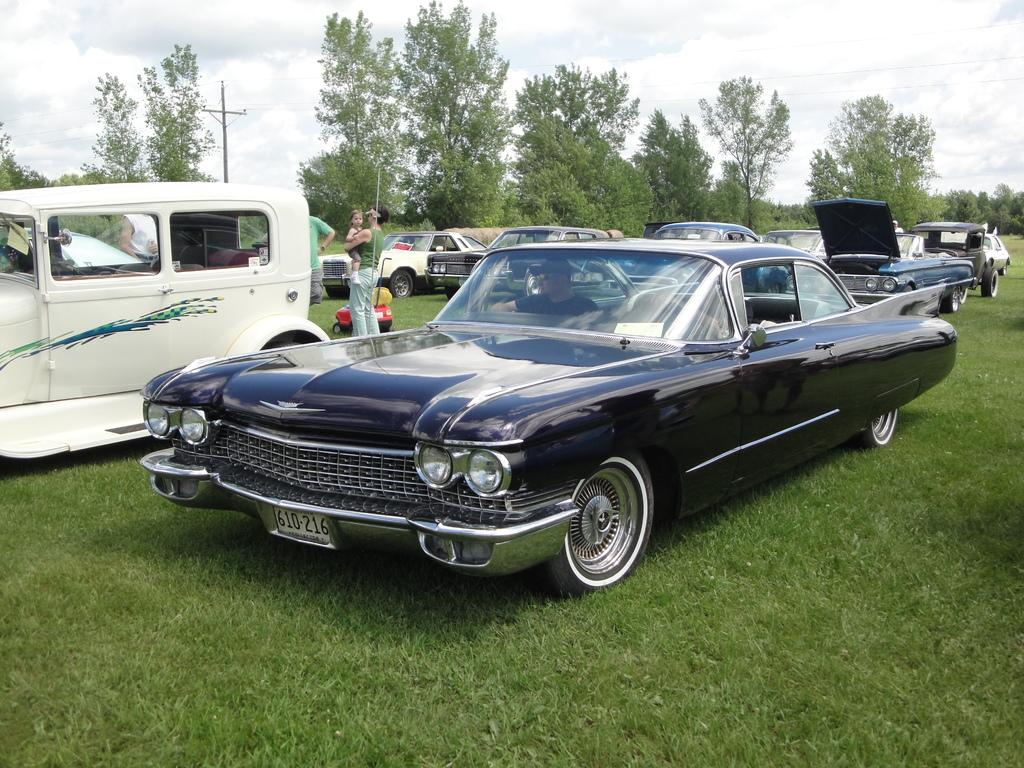What type of objects are on the ground in the image? There are motor vehicles on the ground in the image. Are there any people visible in the image? Yes, there are persons standing in the image. What type of natural elements can be seen in the image? There are trees in the image. What man-made structure is present in the image? There is an electric pole in the image. What part of the natural environment is visible in the image? The sky is visible in the image. What can be observed in the sky? Clouds are present in the sky. What type of news can be heard coming from the electric pole in the image? There is no indication in the image that the electric pole is broadcasting any news, so it's not possible to determine what, if any, news might be heard. 